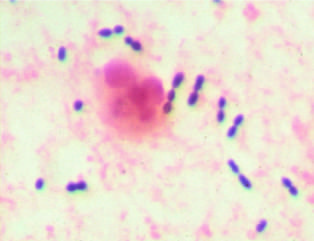s the gram stain preparation of sputum from a patient with pneumonia?
Answer the question using a single word or phrase. Yes 